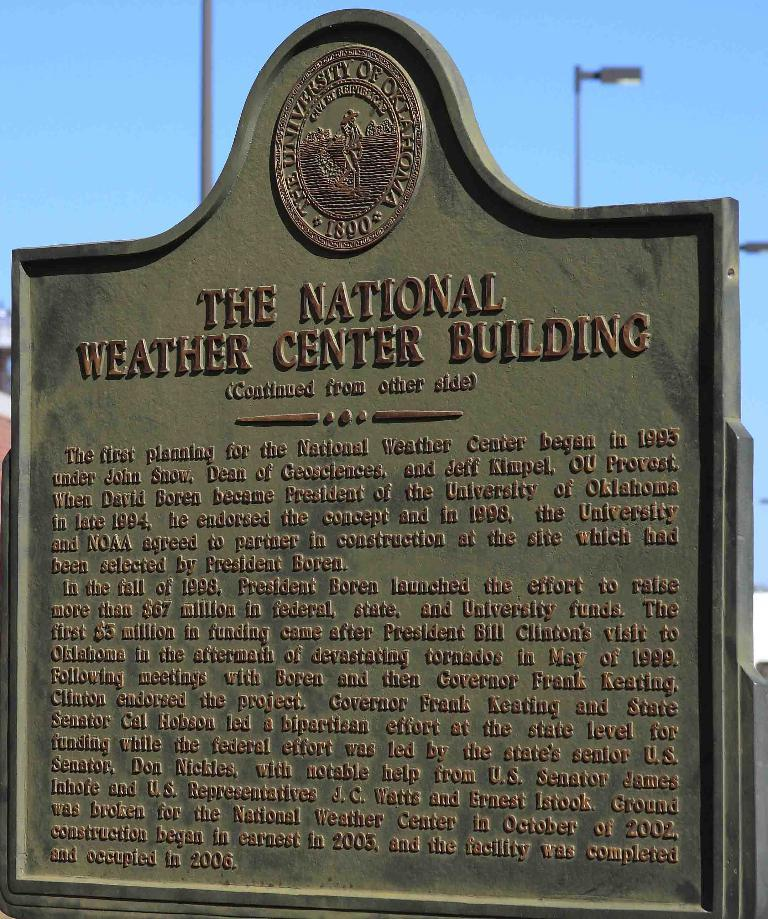Provide a one-sentence caption for the provided image. the national weather center building sign in green. 